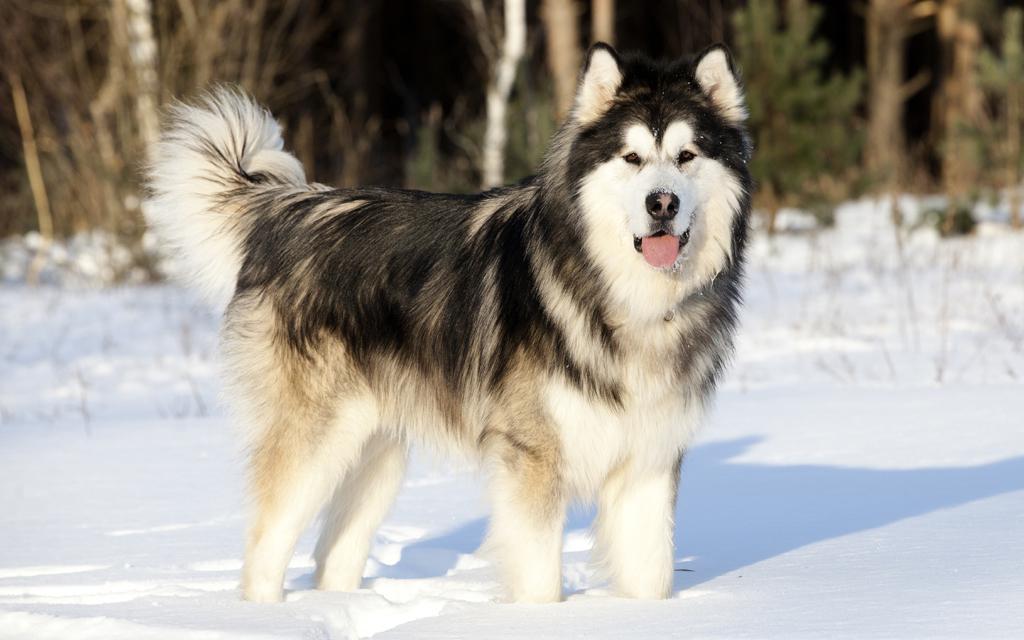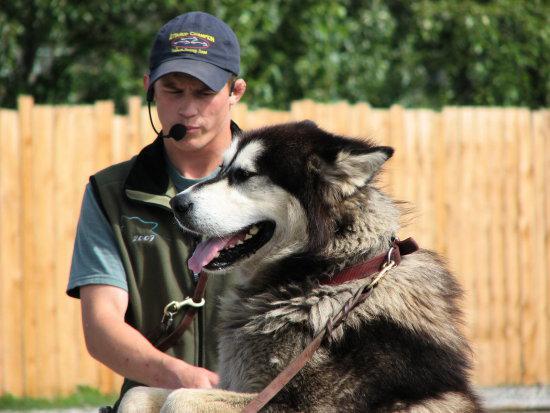The first image is the image on the left, the second image is the image on the right. Evaluate the accuracy of this statement regarding the images: "The dog in one of the images is standing in the grass.". Is it true? Answer yes or no. No. The first image is the image on the left, the second image is the image on the right. Assess this claim about the two images: "a husky is standing in the grass". Correct or not? Answer yes or no. No. 